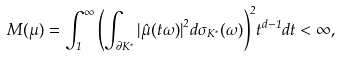<formula> <loc_0><loc_0><loc_500><loc_500>M ( \mu ) = \int _ { 1 } ^ { \infty } { \left ( \int _ { \partial K ^ { * } } { | \hat { \mu } ( t \omega ) | } ^ { 2 } d \sigma _ { K ^ { * } } ( \omega ) \right ) } ^ { 2 } t ^ { d - 1 } d t < \infty ,</formula> 